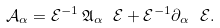<formula> <loc_0><loc_0><loc_500><loc_500>\mathcal { A } _ { \alpha } = \mathcal { E } ^ { - 1 } \, \mathfrak { A } _ { \alpha } \ \mathcal { E } + \mathcal { E } ^ { - 1 } \partial _ { \alpha } \ \mathcal { E } .</formula> 